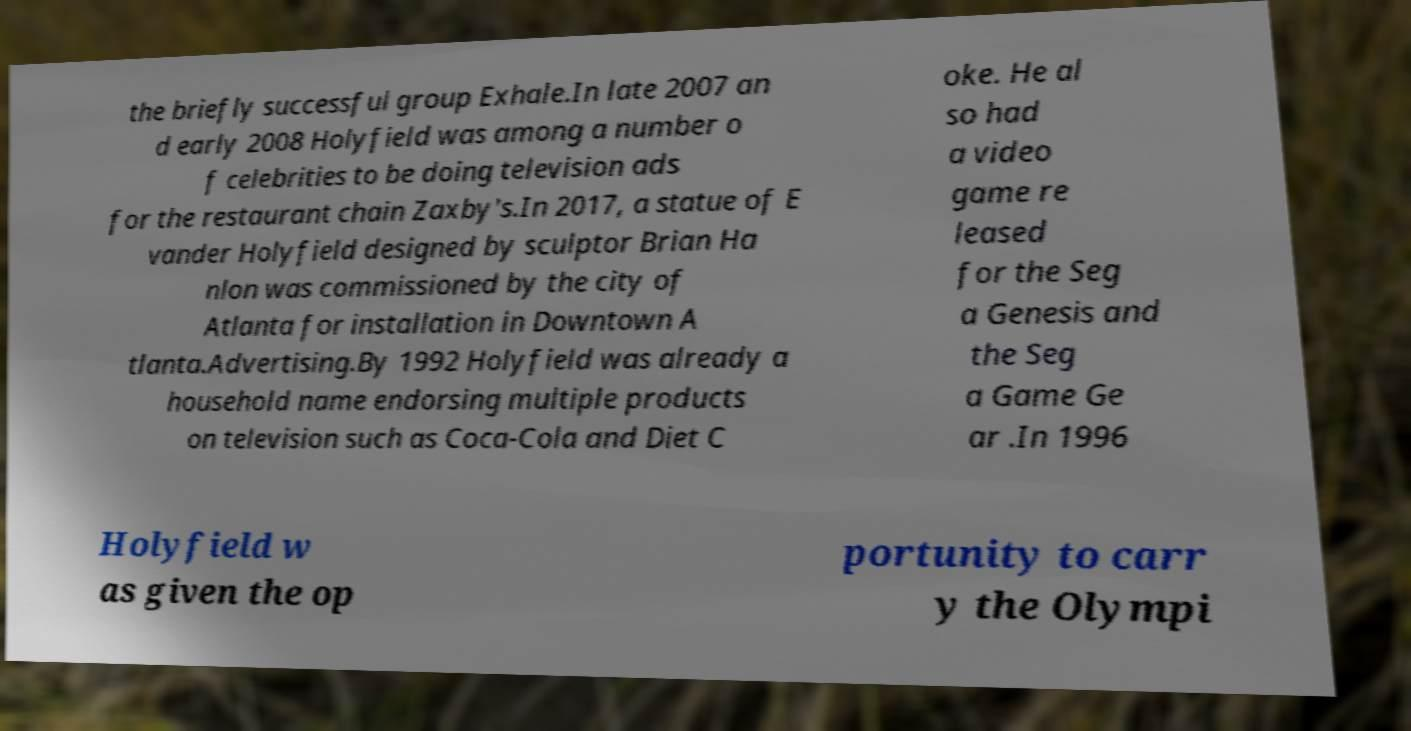Could you assist in decoding the text presented in this image and type it out clearly? the briefly successful group Exhale.In late 2007 an d early 2008 Holyfield was among a number o f celebrities to be doing television ads for the restaurant chain Zaxby's.In 2017, a statue of E vander Holyfield designed by sculptor Brian Ha nlon was commissioned by the city of Atlanta for installation in Downtown A tlanta.Advertising.By 1992 Holyfield was already a household name endorsing multiple products on television such as Coca-Cola and Diet C oke. He al so had a video game re leased for the Seg a Genesis and the Seg a Game Ge ar .In 1996 Holyfield w as given the op portunity to carr y the Olympi 